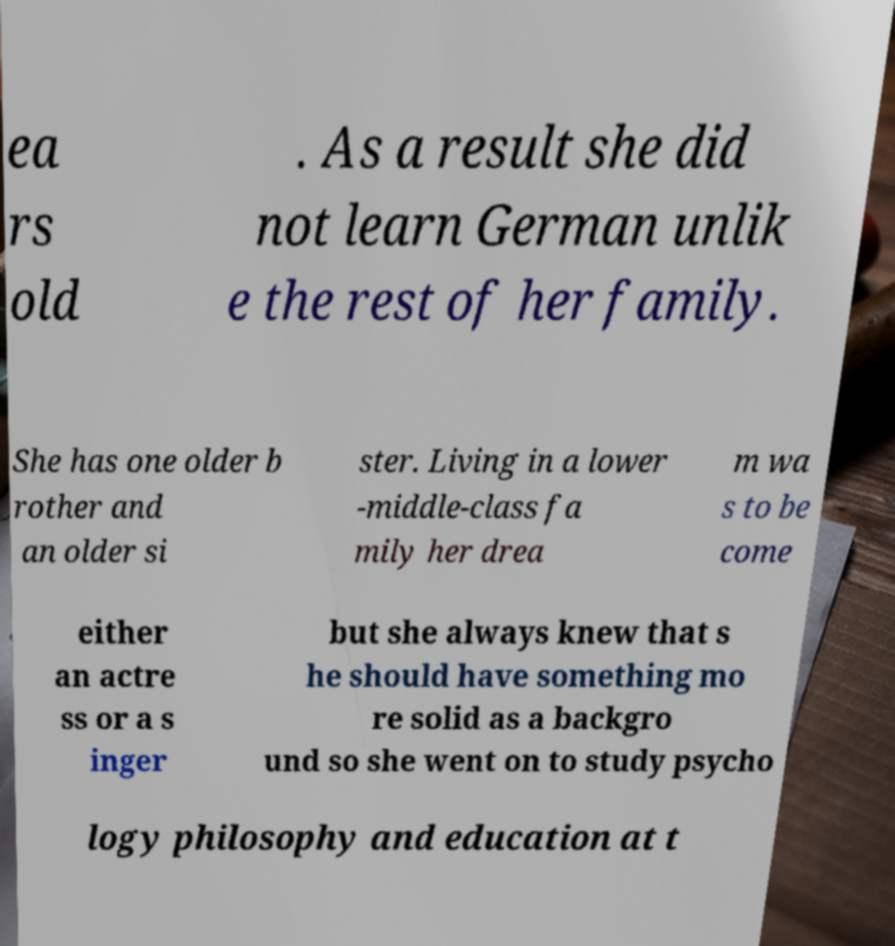Could you extract and type out the text from this image? ea rs old . As a result she did not learn German unlik e the rest of her family. She has one older b rother and an older si ster. Living in a lower -middle-class fa mily her drea m wa s to be come either an actre ss or a s inger but she always knew that s he should have something mo re solid as a backgro und so she went on to study psycho logy philosophy and education at t 